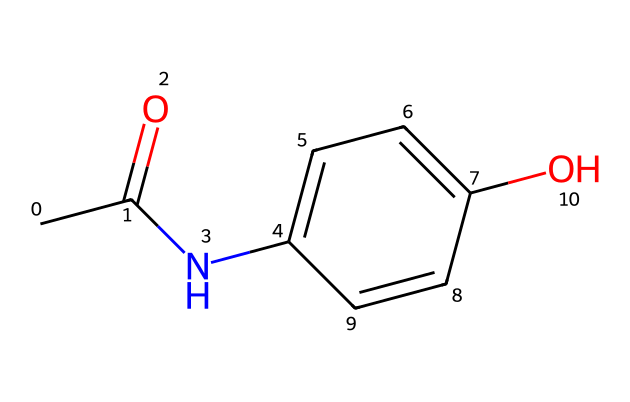What is the molecular formula of acetaminophen? By interpreting the SMILES notation, we can identify that there are 8 carbon atoms (C), 9 hydrogen atoms (H), 1 nitrogen atom (N), and 1 oxygen atom (O) in the chemical structure. Therefore, the molecular formula is C8H9NO2.
Answer: C8H9NO2 How many rings are present in the acetaminophen structure? Examining the SMILES representation, the presence of the "C1" indicates the start of a ring, and the corresponding "C1" later closes it. There is only one ring that consists of a phenolic ring in the structure.
Answer: 1 What functional groups are present in acetaminophen? Analyzing the structure, acetaminophen features a hydroxyl group (-OH) and an amide group (–NH–CO–). These groups contribute to its properties as a pain reliever.
Answer: hydroxyl and amide Is acetaminophen an aromatic compound? The structure contains a benzene ring, which is characterized by alternating double bonds and is a signature of aromatic compounds. This means acetaminophen is indeed aromatic.
Answer: yes What is the position of the hydroxyl group on the ring? The SMILES representation indicates that the hydroxyl group is adjacent to the amide group on the benzene ring, specifically at the position 4 relative to the nitrogen atom in the amide.
Answer: position 4 How many total bonds are in the acetaminophen molecule? By counting the single and double bonds from the structure: each carbon generally forms four bonds. In total, the structure has 10 single bonds and 2 double bonds, summing up to 12 bonds in total.
Answer: 12 